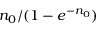Convert formula to latex. <formula><loc_0><loc_0><loc_500><loc_500>n _ { 0 } / ( 1 - e ^ { - n _ { 0 } } )</formula> 